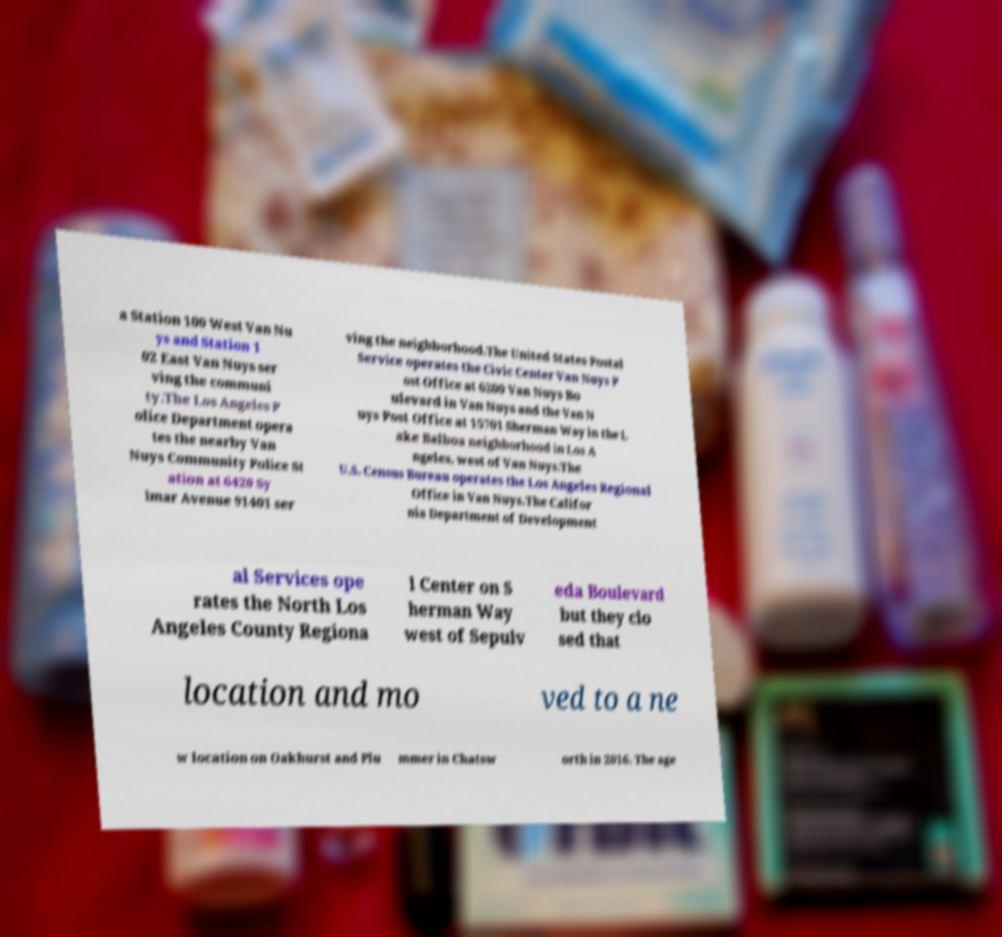Can you accurately transcribe the text from the provided image for me? a Station 100 West Van Nu ys and Station 1 02 East Van Nuys ser ving the communi ty.The Los Angeles P olice Department opera tes the nearby Van Nuys Community Police St ation at 6420 Sy lmar Avenue 91401 ser ving the neighborhood.The United States Postal Service operates the Civic Center Van Nuys P ost Office at 6200 Van Nuys Bo ulevard in Van Nuys and the Van N uys Post Office at 15701 Sherman Way in the L ake Balboa neighborhood in Los A ngeles, west of Van Nuys.The U.S. Census Bureau operates the Los Angeles Regional Office in Van Nuys.The Califor nia Department of Development al Services ope rates the North Los Angeles County Regiona l Center on S herman Way west of Sepulv eda Boulevard but they clo sed that location and mo ved to a ne w location on Oakhurst and Plu mmer in Chatsw orth in 2016. The age 